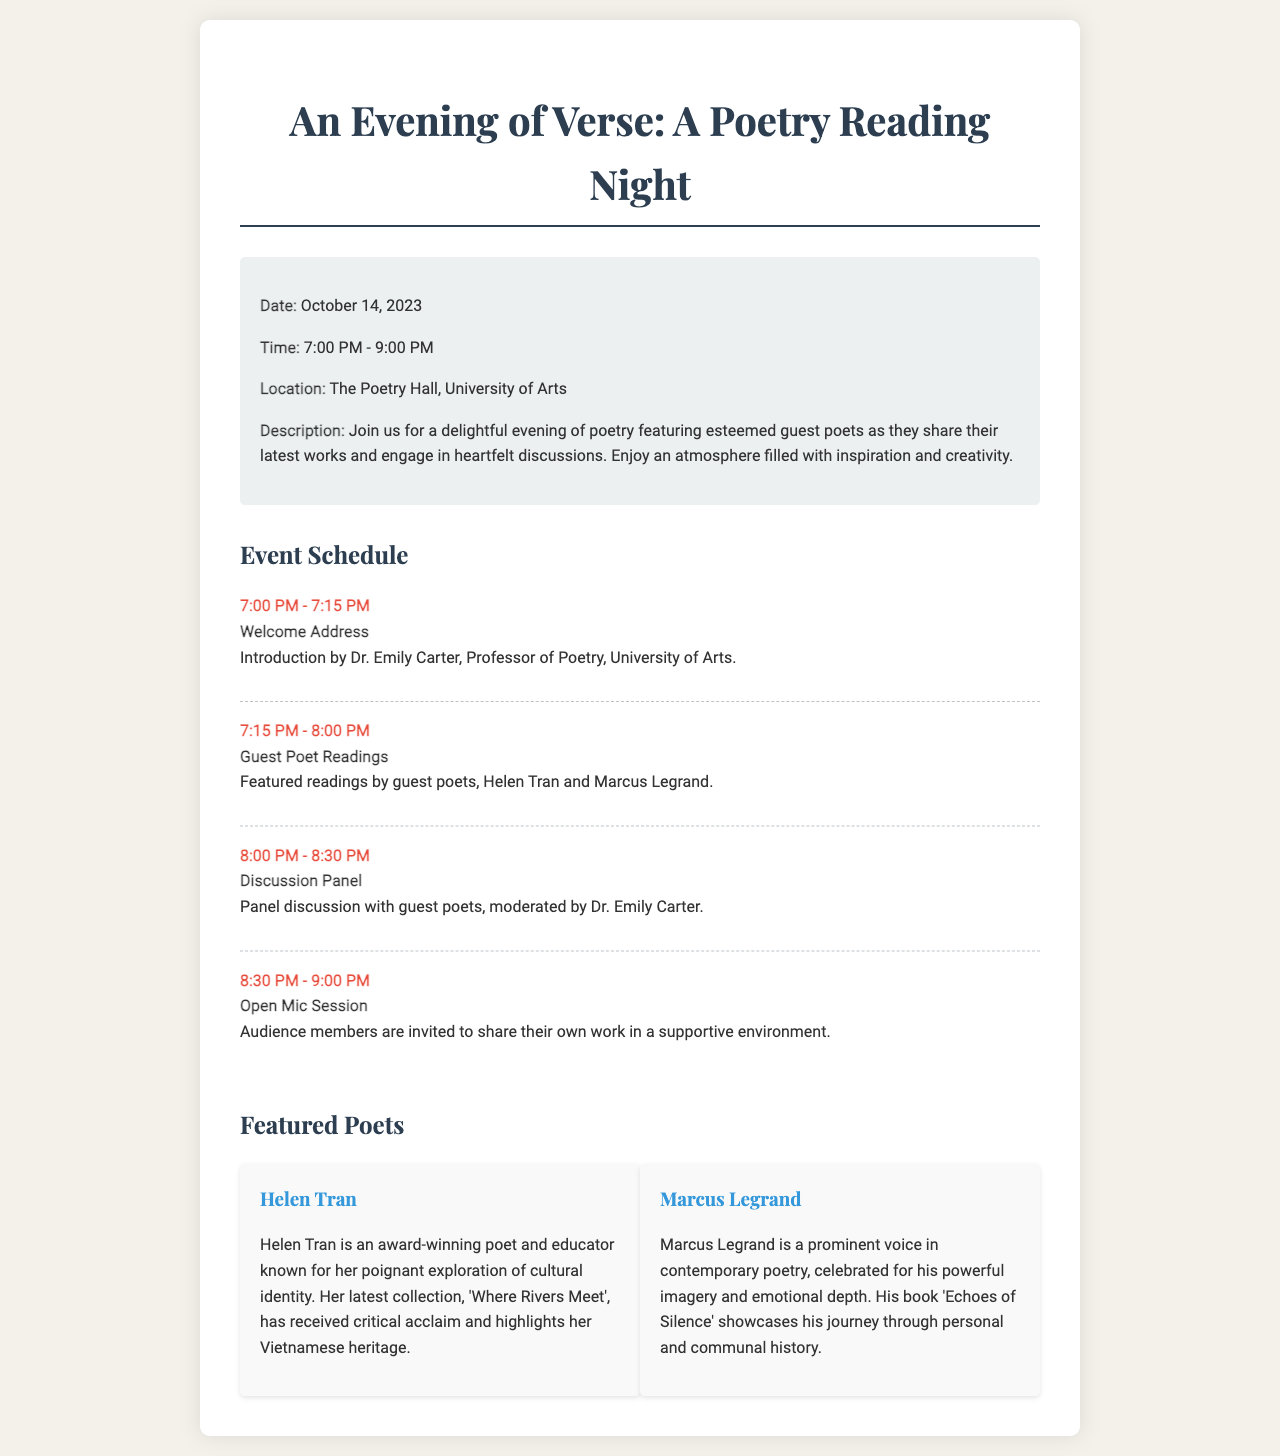What is the date of the event? The event is scheduled for October 14, 2023.
Answer: October 14, 2023 Who is the moderator for the discussion panel? Dr. Emily Carter is the moderator for the discussion panel.
Answer: Dr. Emily Carter What are the names of the guest poets? The guest poets featured are Helen Tran and Marcus Legrand.
Answer: Helen Tran and Marcus Legrand What is the duration of the open mic session? The open mic session lasts for 30 minutes, from 8:30 PM to 9:00 PM.
Answer: 30 minutes What is the title of Helen Tran's latest collection? Helen Tran's latest collection is titled 'Where Rivers Meet'.
Answer: Where Rivers Meet How many parts are in the event schedule? The event schedule consists of four parts: Welcome Address, Guest Poet Readings, Discussion Panel, and Open Mic Session.
Answer: Four parts What type of work does Marcus Legrand focus on? Marcus Legrand's work focuses on contemporary poetry with powerful imagery and emotional depth.
Answer: Contemporary poetry What is the venue for the poetry reading night? The venue for the poetry reading night is The Poetry Hall, University of Arts.
Answer: The Poetry Hall, University of Arts 